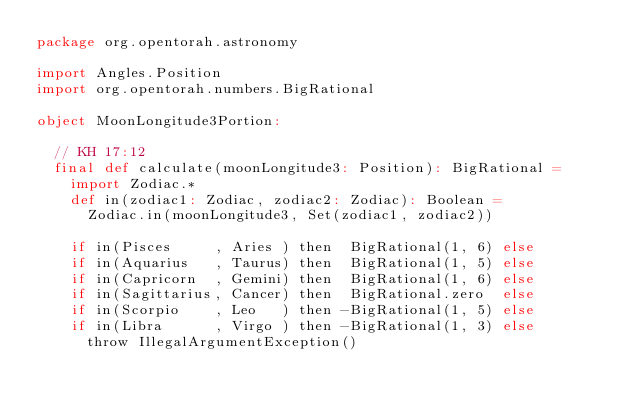Convert code to text. <code><loc_0><loc_0><loc_500><loc_500><_Scala_>package org.opentorah.astronomy

import Angles.Position
import org.opentorah.numbers.BigRational

object MoonLongitude3Portion:

  // KH 17:12
  final def calculate(moonLongitude3: Position): BigRational =
    import Zodiac.*
    def in(zodiac1: Zodiac, zodiac2: Zodiac): Boolean =
      Zodiac.in(moonLongitude3, Set(zodiac1, zodiac2))

    if in(Pisces     , Aries ) then  BigRational(1, 6) else
    if in(Aquarius   , Taurus) then  BigRational(1, 5) else
    if in(Capricorn  , Gemini) then  BigRational(1, 6) else
    if in(Sagittarius, Cancer) then  BigRational.zero  else
    if in(Scorpio    , Leo   ) then -BigRational(1, 5) else
    if in(Libra      , Virgo ) then -BigRational(1, 3) else
      throw IllegalArgumentException()
</code> 